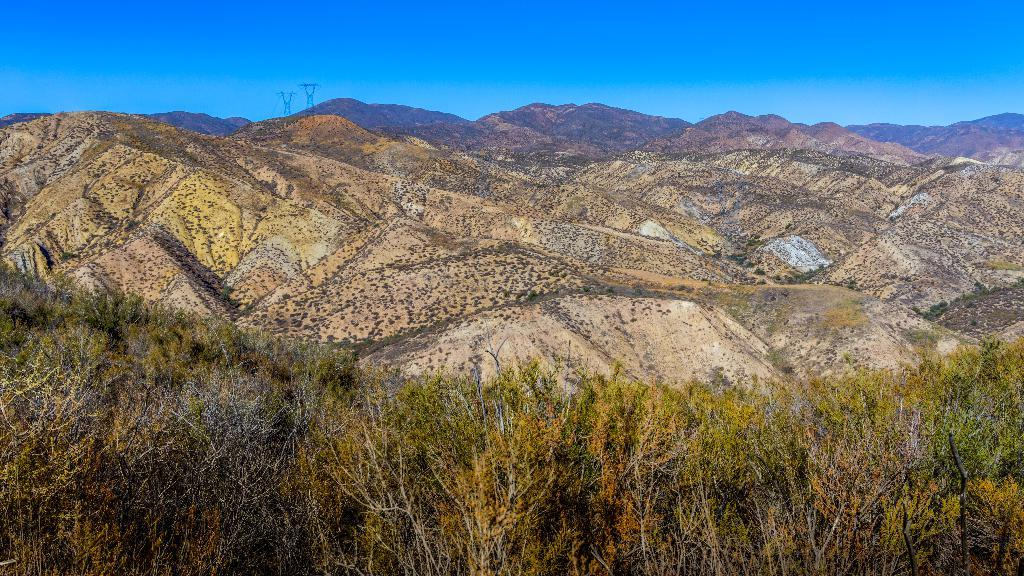What type of natural formation can be seen in the image? There are mountains in the image. What type of vegetation is present in the image? There are trees in the image. What type of man-made structures can be seen in the image? There are towers in the image. What is visible in the background of the image? The sky is visible in the background of the image. Where can the toothpaste be found in the image? There is no toothpaste present in the image. What type of account is being discussed in the image? There is no account being discussed in the image. 